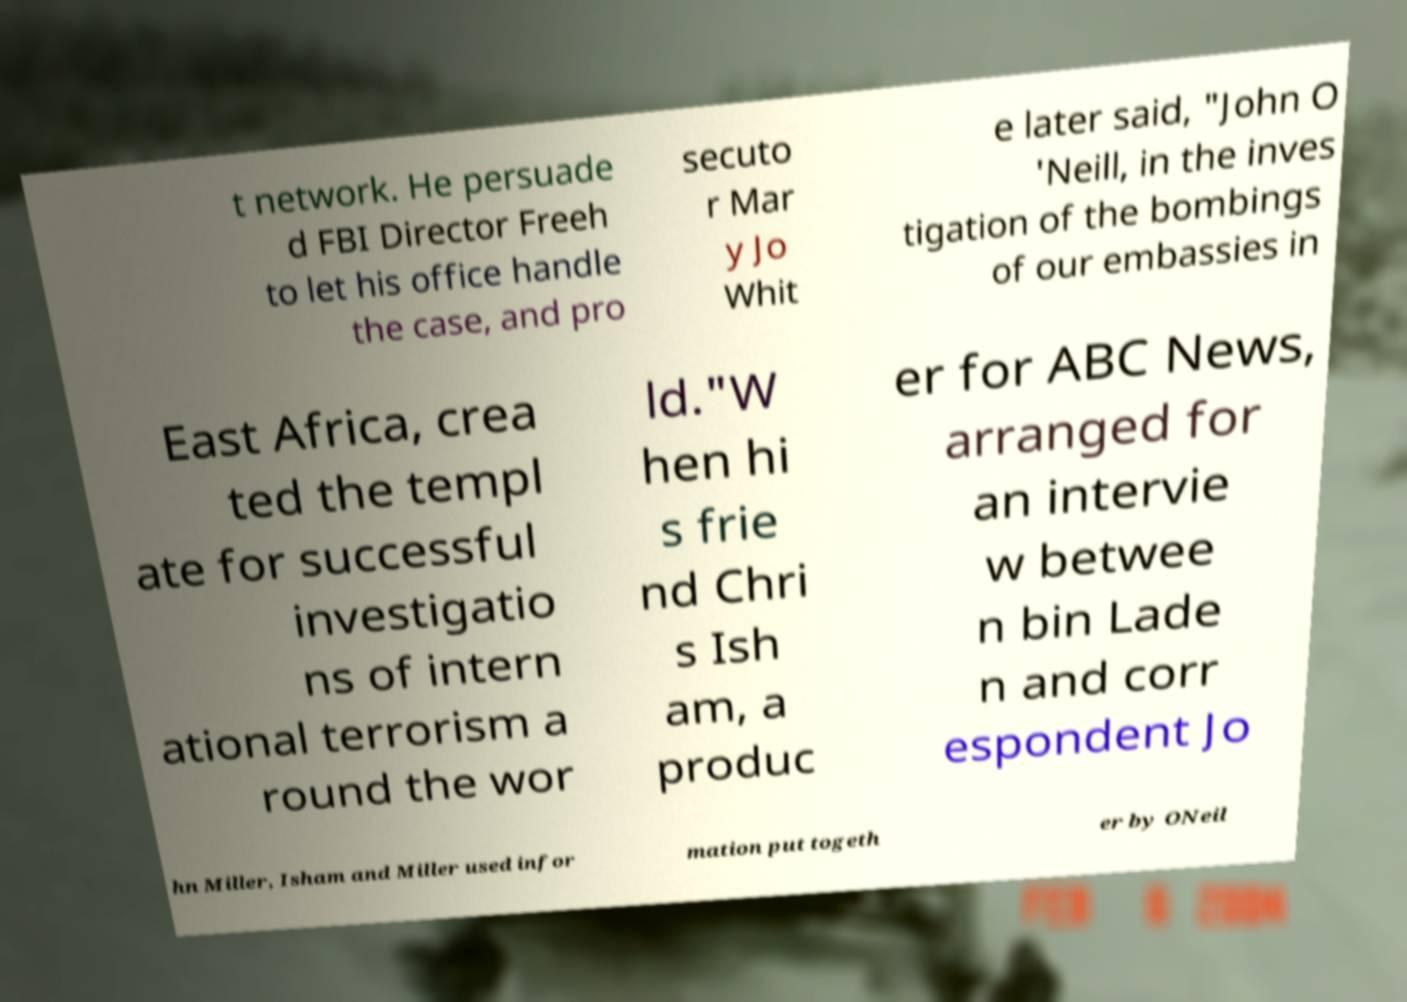Could you assist in decoding the text presented in this image and type it out clearly? t network. He persuade d FBI Director Freeh to let his office handle the case, and pro secuto r Mar y Jo Whit e later said, "John O 'Neill, in the inves tigation of the bombings of our embassies in East Africa, crea ted the templ ate for successful investigatio ns of intern ational terrorism a round the wor ld."W hen hi s frie nd Chri s Ish am, a produc er for ABC News, arranged for an intervie w betwee n bin Lade n and corr espondent Jo hn Miller, Isham and Miller used infor mation put togeth er by ONeil 